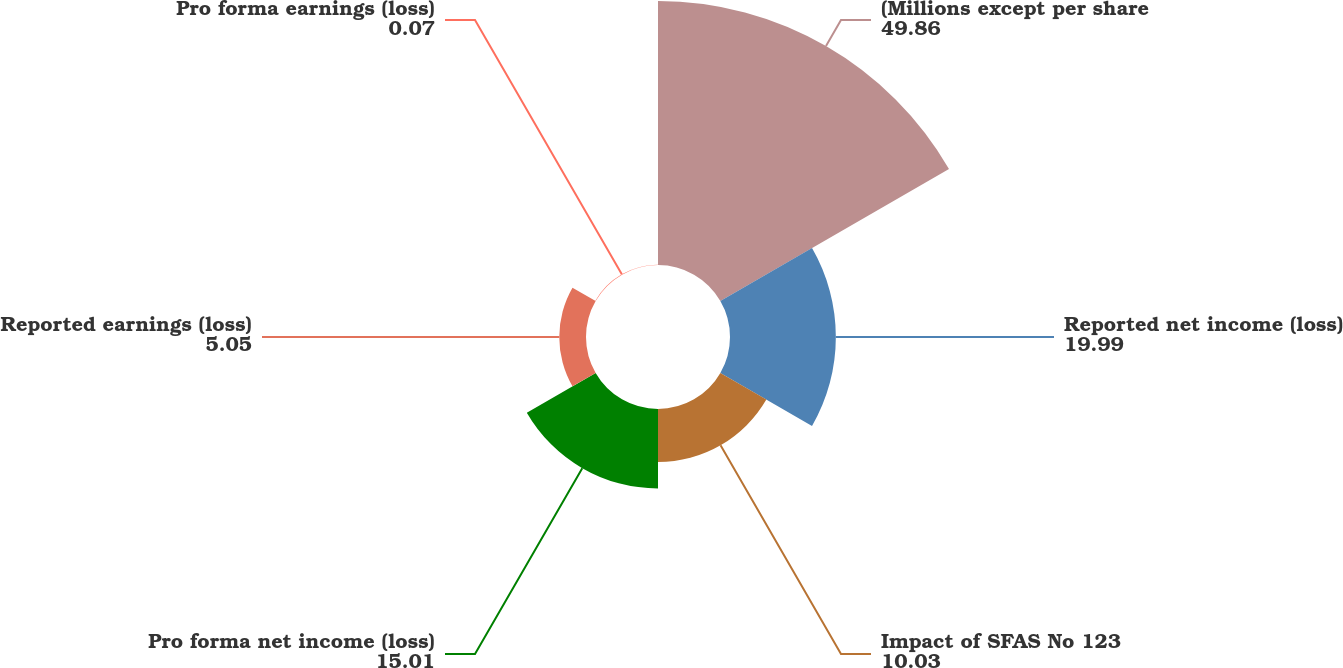Convert chart. <chart><loc_0><loc_0><loc_500><loc_500><pie_chart><fcel>(Millions except per share<fcel>Reported net income (loss)<fcel>Impact of SFAS No 123<fcel>Pro forma net income (loss)<fcel>Reported earnings (loss)<fcel>Pro forma earnings (loss)<nl><fcel>49.86%<fcel>19.99%<fcel>10.03%<fcel>15.01%<fcel>5.05%<fcel>0.07%<nl></chart> 